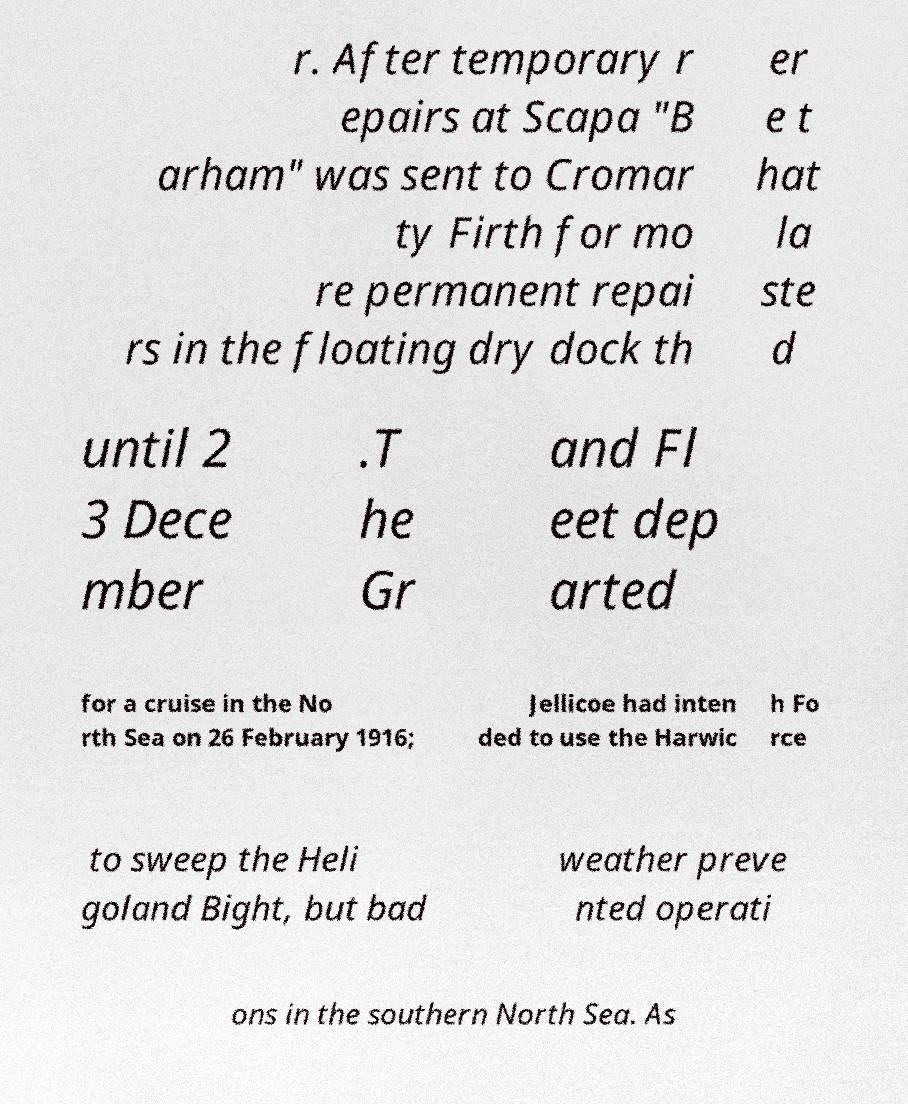For documentation purposes, I need the text within this image transcribed. Could you provide that? r. After temporary r epairs at Scapa "B arham" was sent to Cromar ty Firth for mo re permanent repai rs in the floating dry dock th er e t hat la ste d until 2 3 Dece mber .T he Gr and Fl eet dep arted for a cruise in the No rth Sea on 26 February 1916; Jellicoe had inten ded to use the Harwic h Fo rce to sweep the Heli goland Bight, but bad weather preve nted operati ons in the southern North Sea. As 